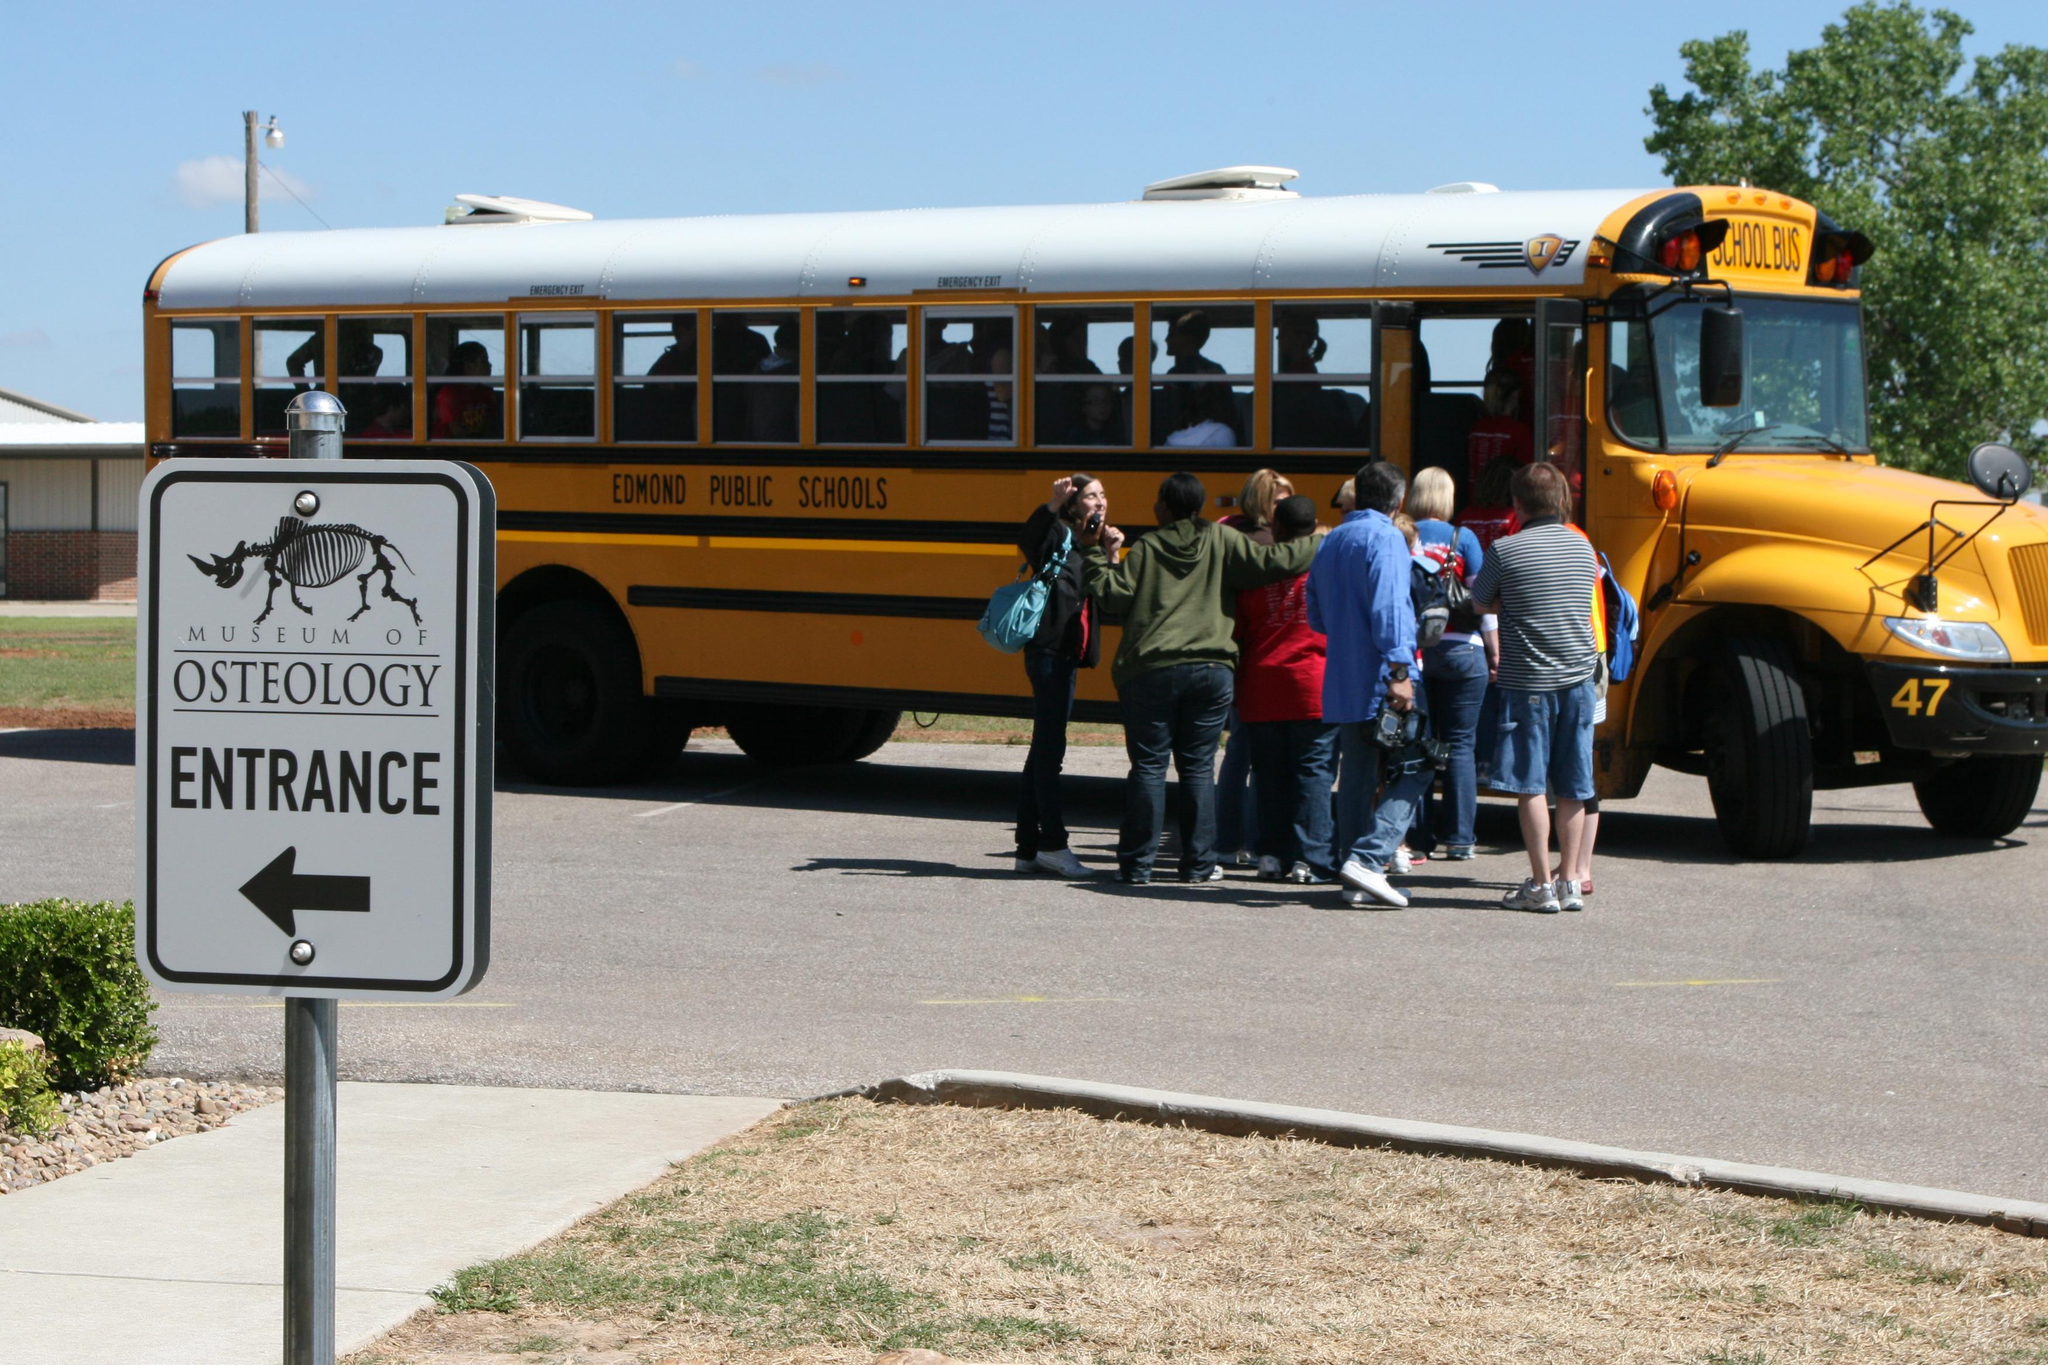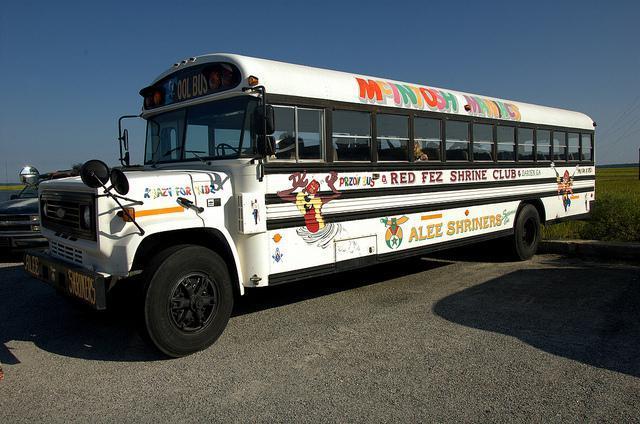The first image is the image on the left, the second image is the image on the right. Given the left and right images, does the statement "One image shows a bus decorated with some type of 'artwork', and the other image shows a bus with severe impact damage on its front end." hold true? Answer yes or no. No. The first image is the image on the left, the second image is the image on the right. For the images displayed, is the sentence "In one image there is a single schoolbus that has been involved in an accident and is wrecked in the center of the image." factually correct? Answer yes or no. No. 